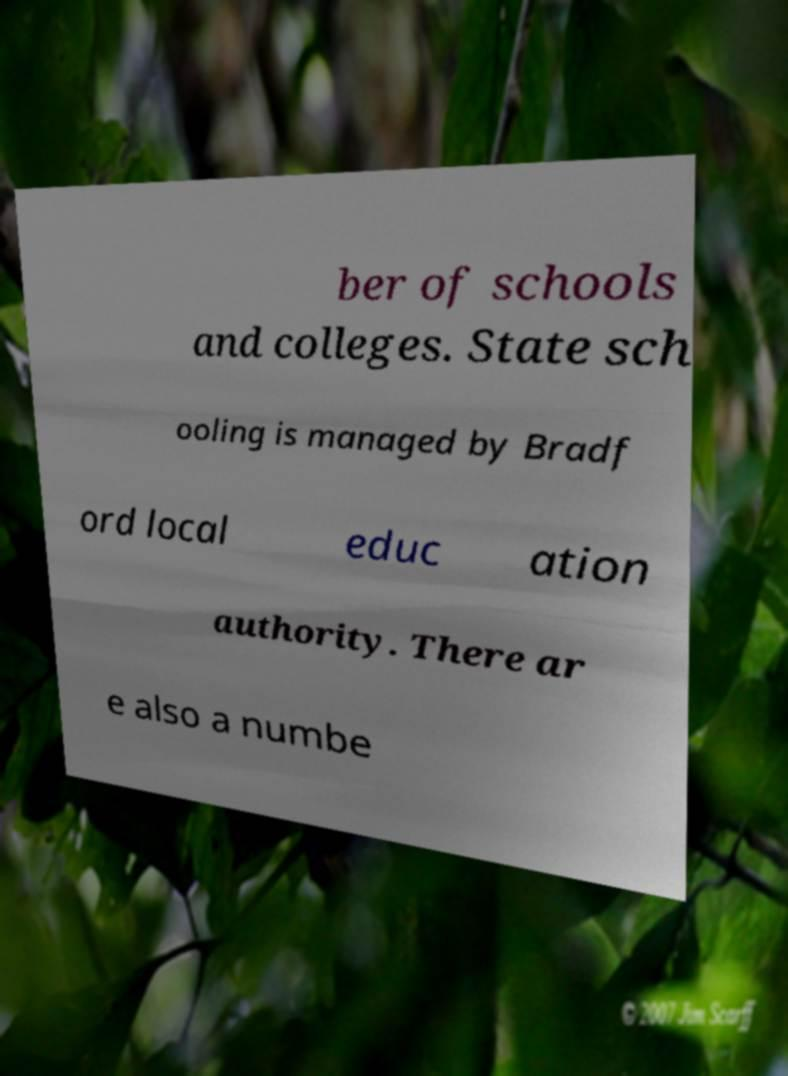I need the written content from this picture converted into text. Can you do that? ber of schools and colleges. State sch ooling is managed by Bradf ord local educ ation authority. There ar e also a numbe 